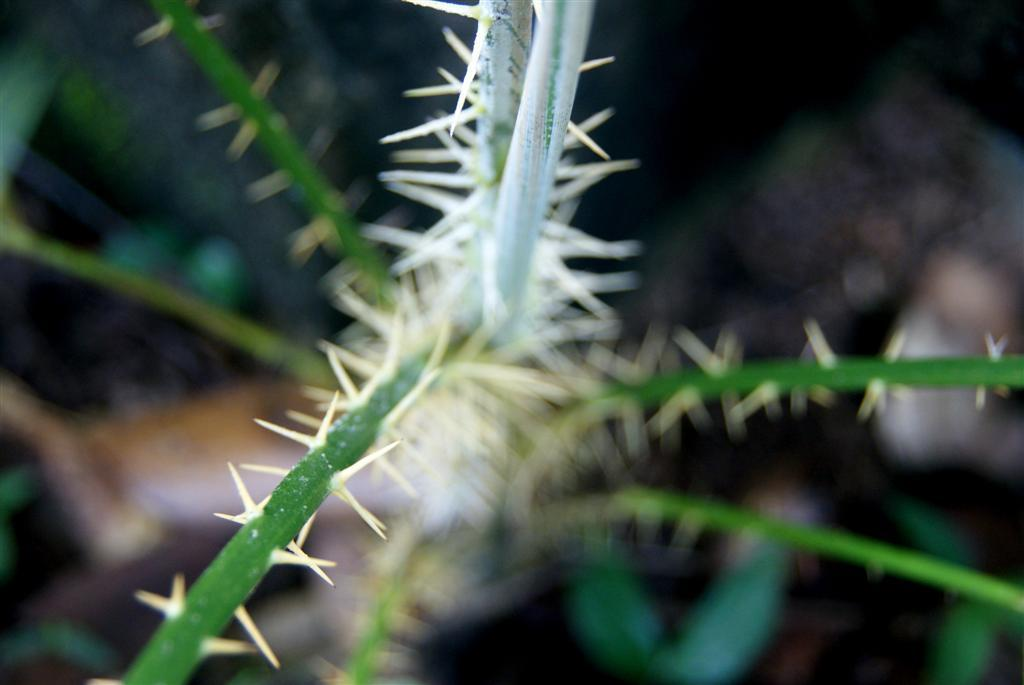What type of vegetation is present in the image? There are green stems in the image. What feature can be observed on the green stems? There are thorns in the image. Can you describe the background of the image? The background of the image is blurred. What type of camp can be seen in the background of the image? There is no camp present in the image; the background is blurred. Can you tell me how many airplanes are visible in the image? There are no airplanes present in the image. What type of book is the person reading in the image? There is no person reading a book in the image. 